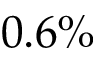<formula> <loc_0><loc_0><loc_500><loc_500>0 . 6 \%</formula> 